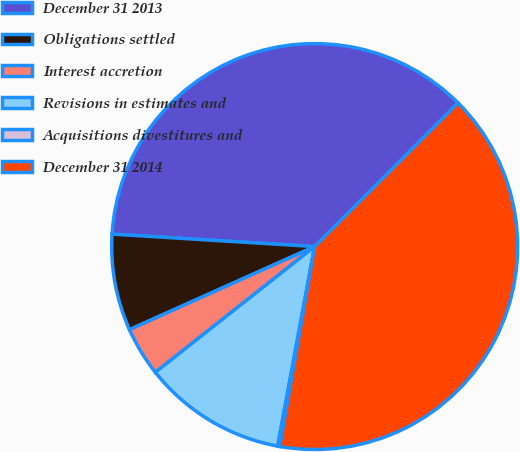Convert chart to OTSL. <chart><loc_0><loc_0><loc_500><loc_500><pie_chart><fcel>December 31 2013<fcel>Obligations settled<fcel>Interest accretion<fcel>Revisions in estimates and<fcel>Acquisitions divestitures and<fcel>December 31 2014<nl><fcel>36.51%<fcel>7.69%<fcel>3.92%<fcel>11.45%<fcel>0.16%<fcel>40.27%<nl></chart> 